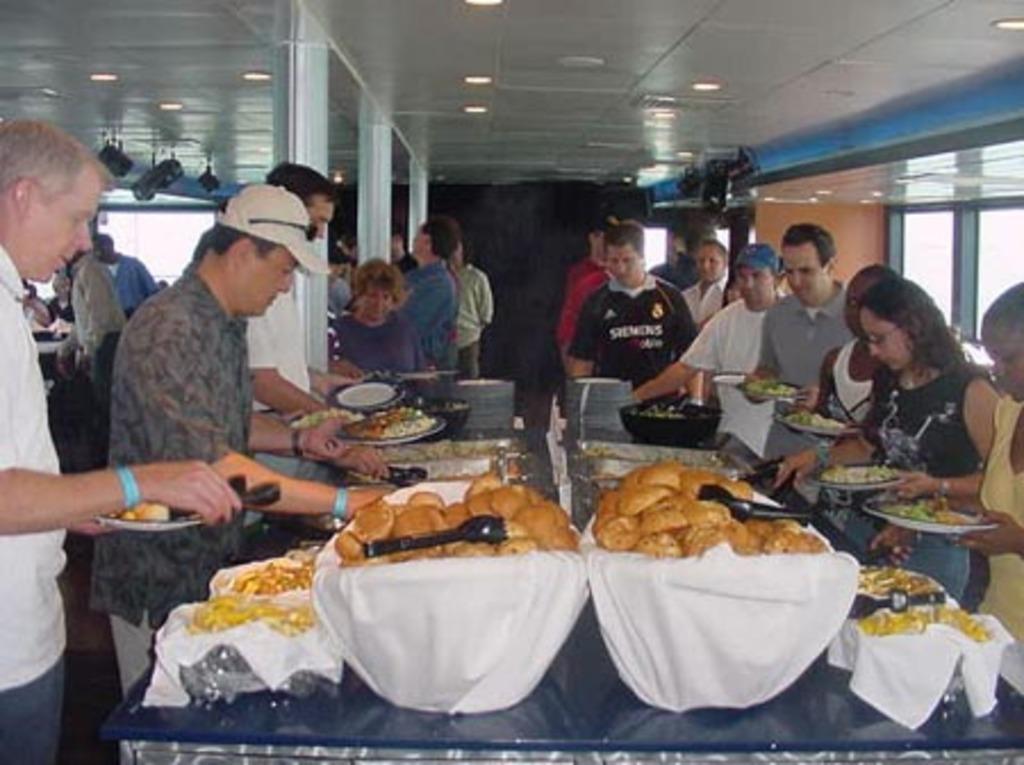How would you summarize this image in a sentence or two? In front of the image there is a table. On top of it there are plates, food items and a few other objects. There are a few people holding the plates and there are a few people standing. On the right side of the image there are glass windows. In the background of the image there are pillars. There is a wall. On top of the image there are lights. 